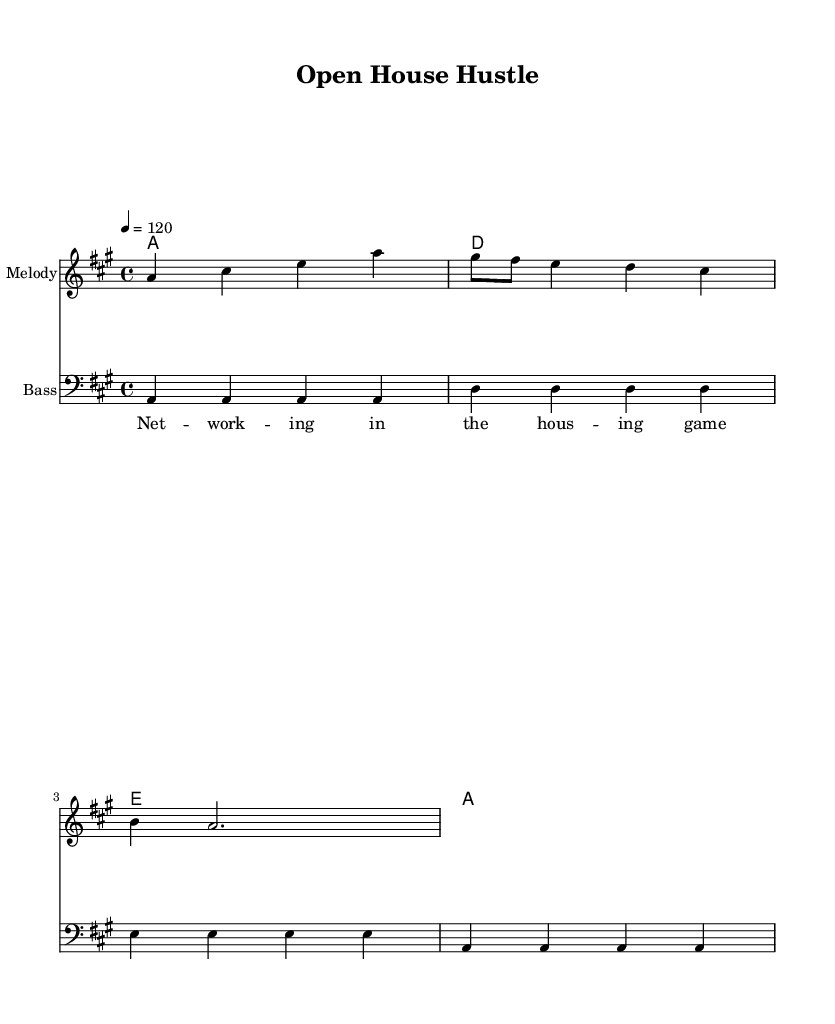What is the key signature of this music? The key signature is set to A major, indicated by three sharps (F#, C#, and G#). You can identify the key signature by looking for sharp symbols placed on the staff at the beginning of the piece.
Answer: A major What is the time signature of this music? The time signature displayed is 4/4, which means there are four beats in a measure and the quarter note gets one beat. This is typically noted at the beginning of the score, and is a common time signature for disco music.
Answer: 4/4 What is the tempo marking of this piece? The tempo marking indicates the speed of the music, which is set at 120 beats per minute (bpm). This is explicitly stated in the score, signifying the pace at which the piece should be played.
Answer: 120 What are the first three notes of the melody? The first three notes of the melody are A, C#, and E. By examining the first measure of the melody line, we can distinguish these specific pitches as they are indicated directly on the staff.
Answer: A, C#, E How many measures are in the provided music? The music consists of four measures. We can identify the number of measures by counting the vertical lines (bar lines) that divide the staff into segments. Each bar line indicates the end of a measure.
Answer: Four What is the name of the song? The title of the song is "Open House Hustle," which is prominently displayed at the top of the sheet music. This straightforwardly provides the name of the composition you are reviewing.
Answer: Open House Hustle What musical genre does this piece belong to? This piece belongs to the Disco genre, which can be inferred not only from the title but also from the lively tempo and upbeat rhythm typical of disco music.
Answer: Disco 